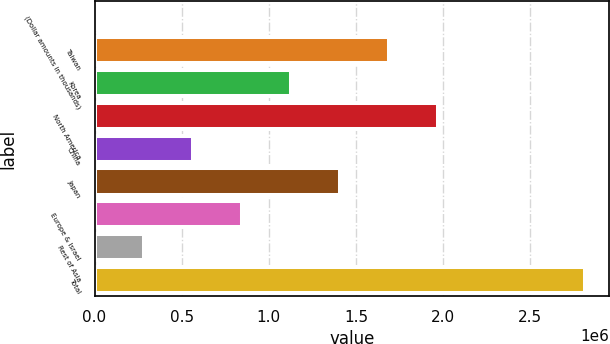Convert chart to OTSL. <chart><loc_0><loc_0><loc_500><loc_500><bar_chart><fcel>(Dollar amounts in thousands)<fcel>Taiwan<fcel>Korea<fcel>North America<fcel>China<fcel>Japan<fcel>Europe & Israel<fcel>Rest of Asia<fcel>Total<nl><fcel>2015<fcel>1.68924e+06<fcel>1.12683e+06<fcel>1.97044e+06<fcel>564422<fcel>1.40803e+06<fcel>845625<fcel>283218<fcel>2.81405e+06<nl></chart> 